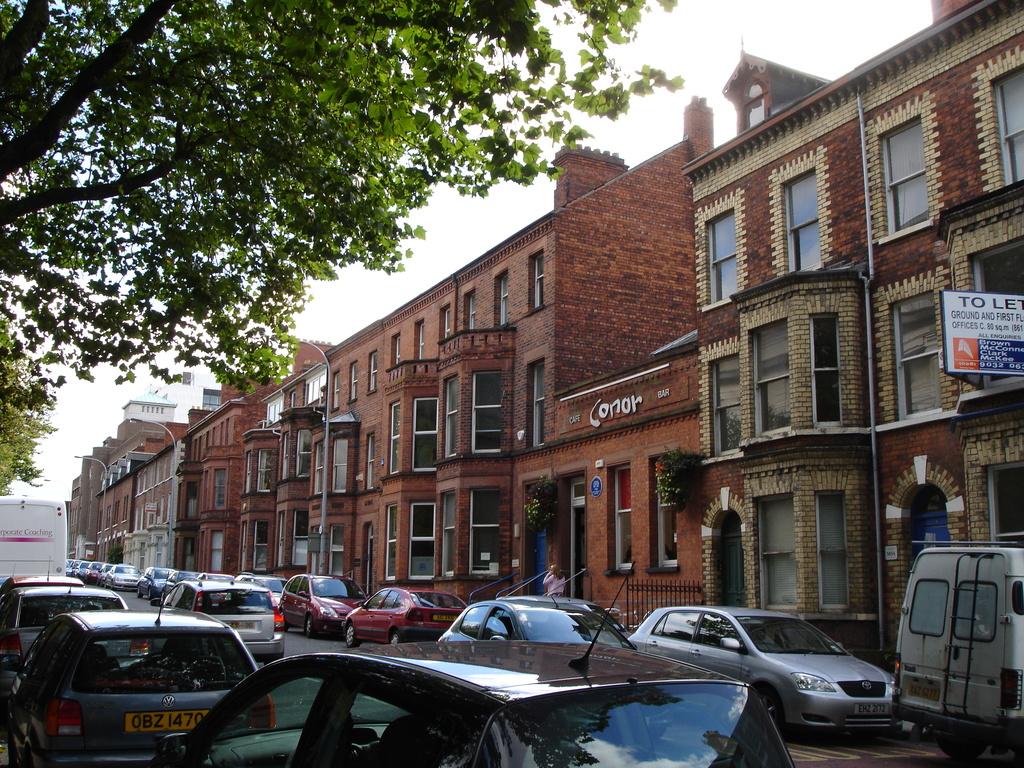What is the name of the cafe?
Ensure brevity in your answer.  Conor. 